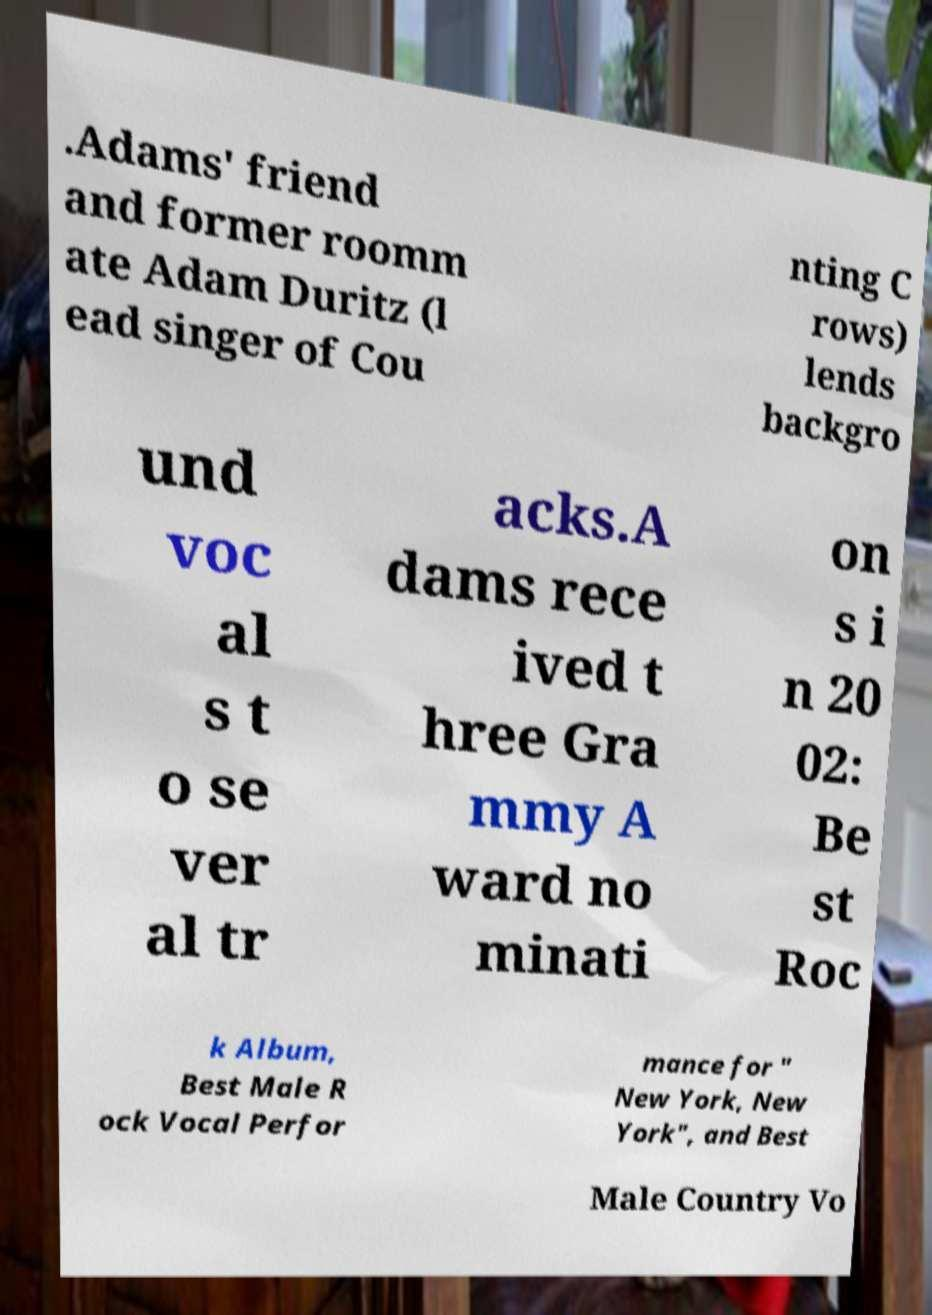I need the written content from this picture converted into text. Can you do that? .Adams' friend and former roomm ate Adam Duritz (l ead singer of Cou nting C rows) lends backgro und voc al s t o se ver al tr acks.A dams rece ived t hree Gra mmy A ward no minati on s i n 20 02: Be st Roc k Album, Best Male R ock Vocal Perfor mance for " New York, New York", and Best Male Country Vo 